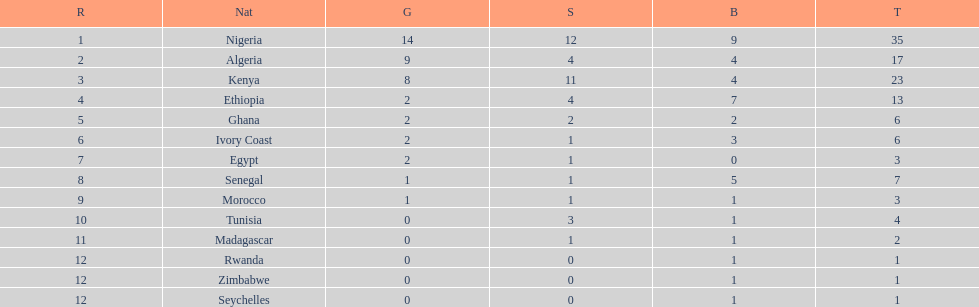Which nations have won only one medal? Rwanda, Zimbabwe, Seychelles. 